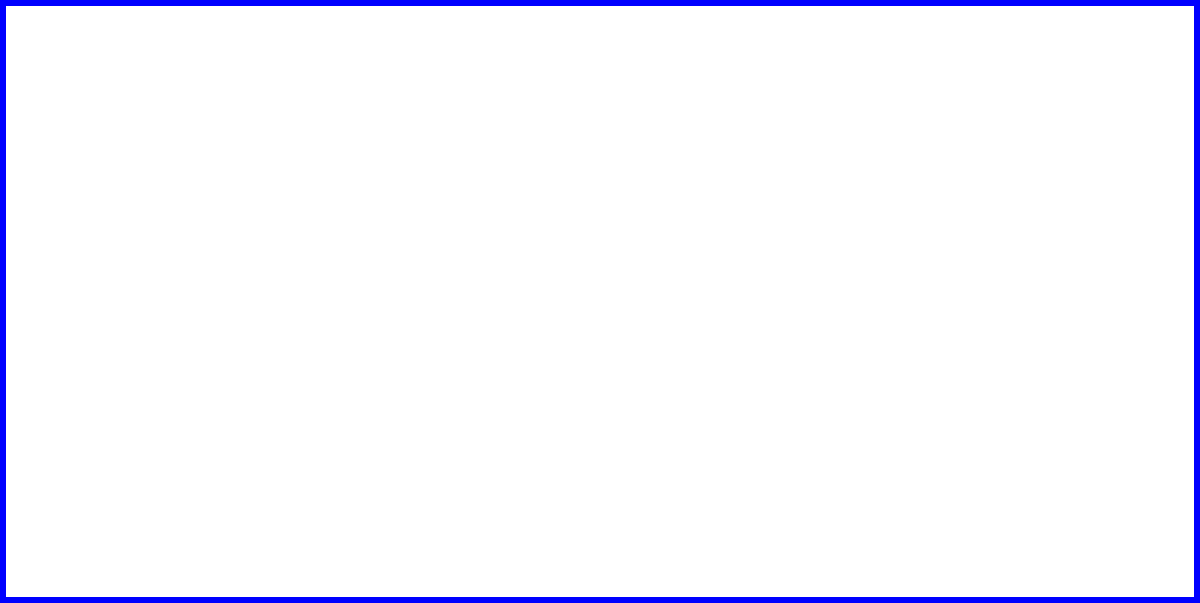As a homeschooling parent, you're teaching your children about thermodynamics while on a diplomatic mission. Using the pressure-volume diagram provided, calculate the efficiency of this heat engine. Assume the working fluid is an ideal gas and the process is reversible. The heat input ($Q_{in}$) occurs during the constant pressure expansion from state 1 to state 2, and the heat output ($Q_{out}$) occurs during the constant pressure compression from state 3 to state 4. To calculate the efficiency of a heat engine, we use the formula:

$$ \eta = 1 - \frac{Q_{out}}{Q_{in}} $$

For an ideal gas undergoing a constant pressure process:

$$ Q = P \Delta V $$

Step 1: Calculate $Q_{in}$ (process 1 to 2)
$$ Q_{in} = P_{1-2} (V_2 - V_1) = 1 (2 - 1) = 1 $$

Step 2: Calculate $Q_{out}$ (process 3 to 4)
$$ Q_{out} = P_{3-4} (V_3 - V_4) = 3 (2 - 1) = 3 $$

Step 3: Calculate efficiency
$$ \eta = 1 - \frac{Q_{out}}{Q_{in}} = 1 - \frac{3}{1} = -2 $$

Step 4: Convert to percentage
$$ \eta = -2 \times 100\% = -200\% $$

The negative efficiency indicates that this is not a heat engine, but rather a heat pump or refrigerator, which requires work input to move heat from a cold reservoir to a hot reservoir.
Answer: $-200\%$ 